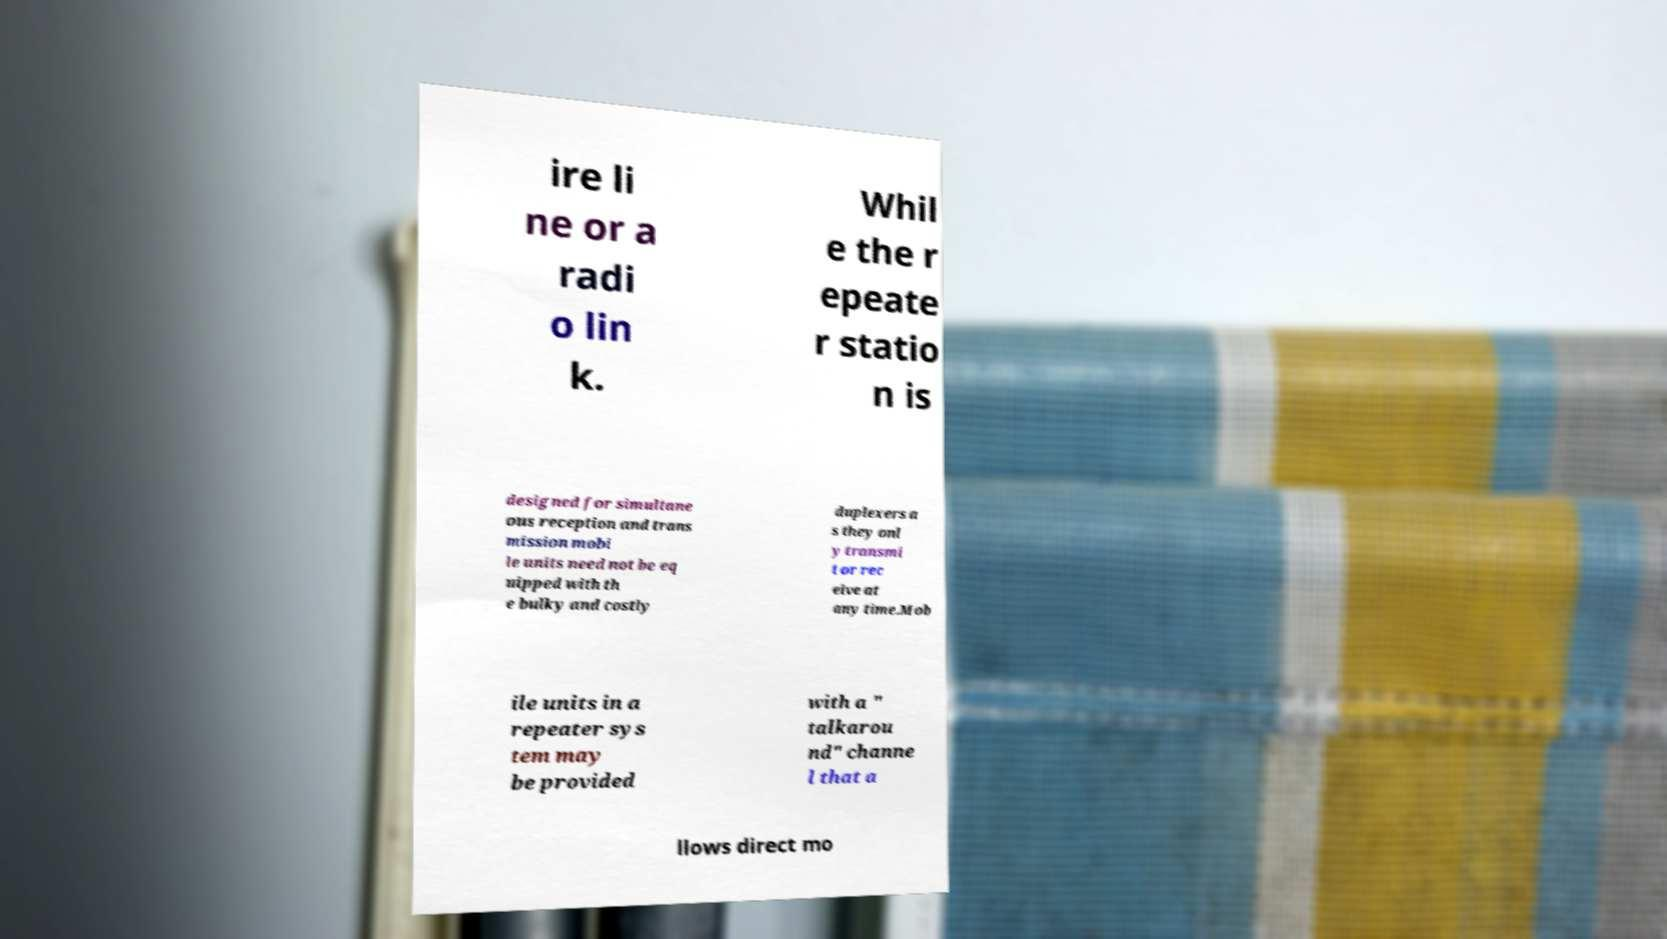Please read and relay the text visible in this image. What does it say? ire li ne or a radi o lin k. Whil e the r epeate r statio n is designed for simultane ous reception and trans mission mobi le units need not be eq uipped with th e bulky and costly duplexers a s they onl y transmi t or rec eive at any time.Mob ile units in a repeater sys tem may be provided with a " talkarou nd" channe l that a llows direct mo 